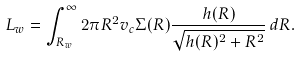<formula> <loc_0><loc_0><loc_500><loc_500>L _ { w } = \int _ { R _ { w } } ^ { \infty } 2 \pi R ^ { 2 } v _ { c } \Sigma ( R ) \frac { h ( R ) } { \sqrt { h ( R ) ^ { 2 } + R ^ { 2 } } } \, d R .</formula> 